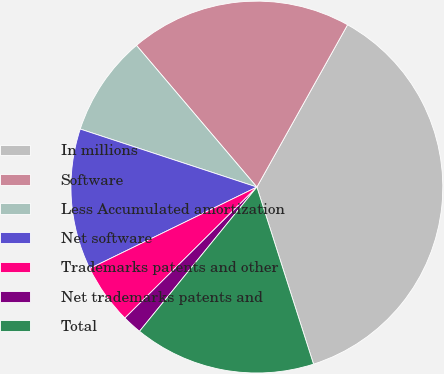Convert chart. <chart><loc_0><loc_0><loc_500><loc_500><pie_chart><fcel>In millions<fcel>Software<fcel>Less Accumulated amortization<fcel>Net software<fcel>Trademarks patents and other<fcel>Net trademarks patents and<fcel>Total<nl><fcel>36.96%<fcel>19.32%<fcel>8.74%<fcel>12.27%<fcel>5.22%<fcel>1.69%<fcel>15.8%<nl></chart> 